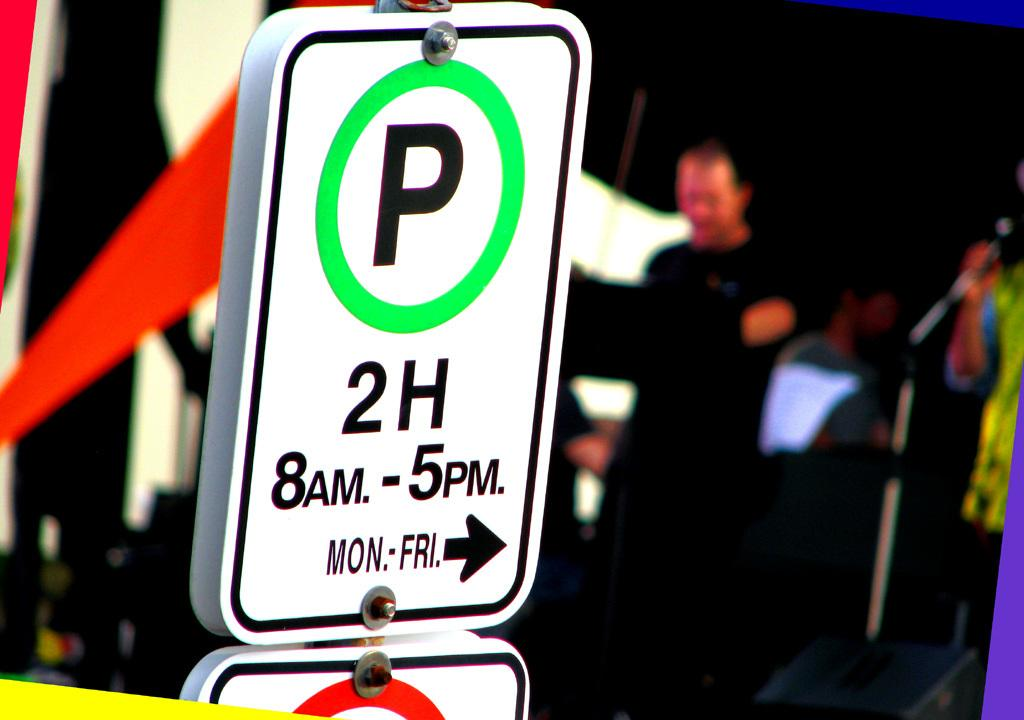<image>
Offer a succinct explanation of the picture presented. A sign that says P in a green circle has 8am-5pm MON-FRI written beneath 